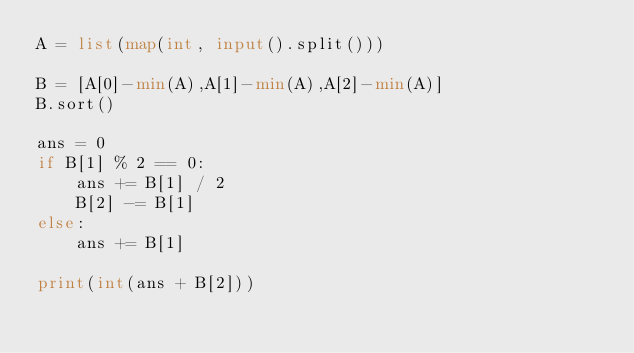Convert code to text. <code><loc_0><loc_0><loc_500><loc_500><_Python_>A = list(map(int, input().split()))

B = [A[0]-min(A),A[1]-min(A),A[2]-min(A)]
B.sort()

ans = 0
if B[1] % 2 == 0:
    ans += B[1] / 2
    B[2] -= B[1]
else:
    ans += B[1]

print(int(ans + B[2]))

</code> 